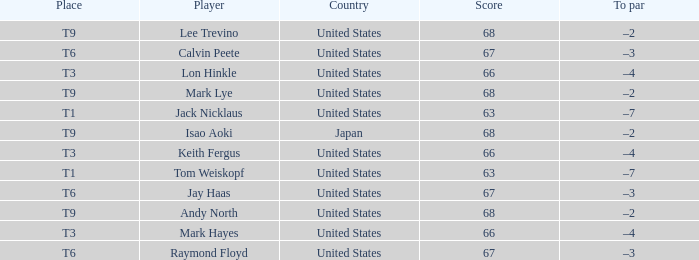What is the nation, when location is t6, and when participant is "raymond floyd"? United States. 